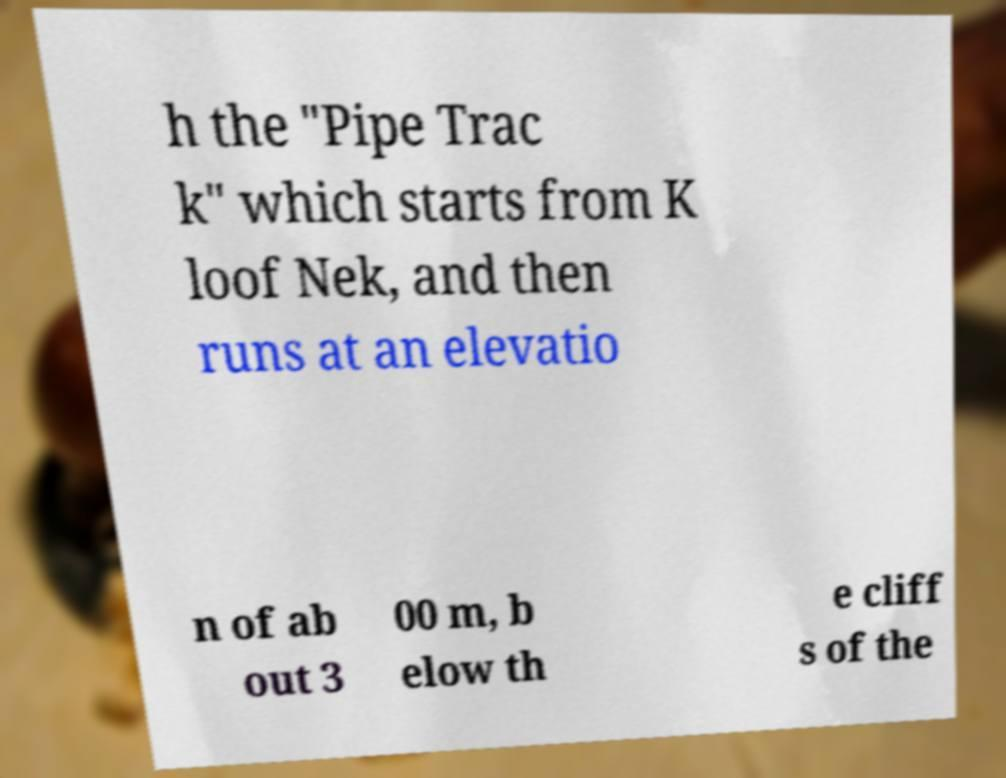What messages or text are displayed in this image? I need them in a readable, typed format. h the "Pipe Trac k" which starts from K loof Nek, and then runs at an elevatio n of ab out 3 00 m, b elow th e cliff s of the 